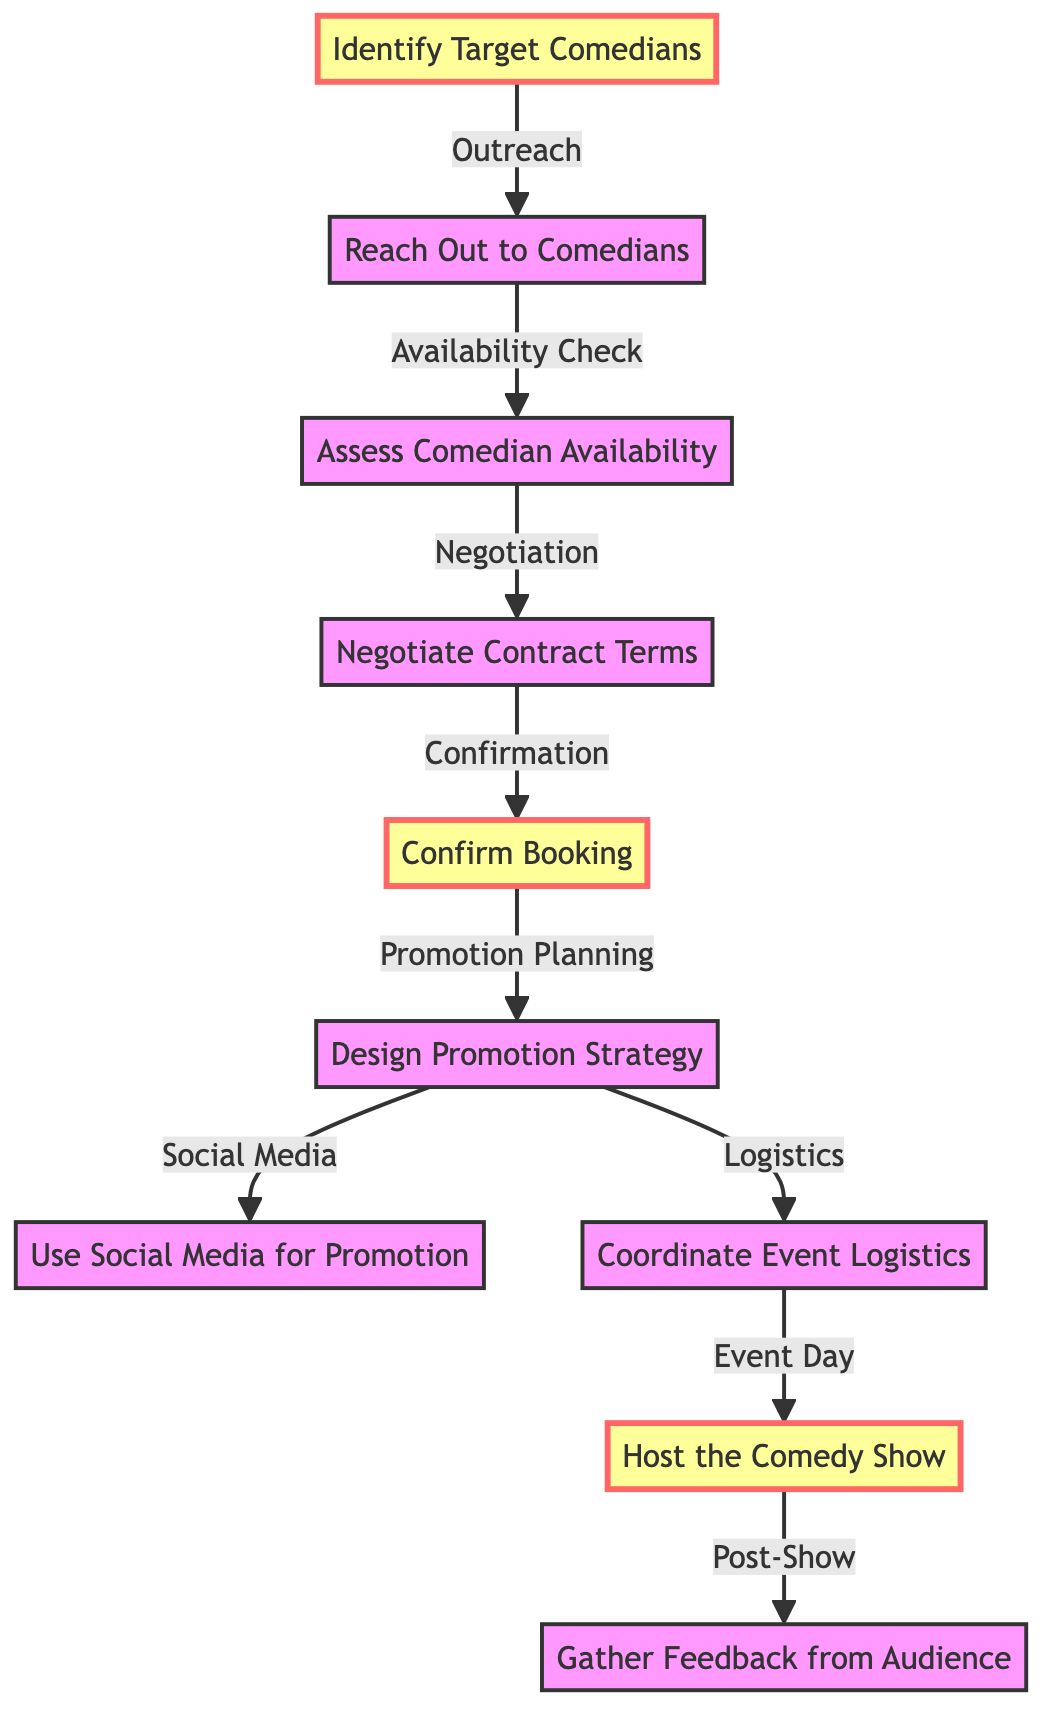What is the first step in the comedy show booking process? The diagram shows that the first step is represented by node "1", which is "Identify Target Comedians".
Answer: Identify Target Comedians How many total nodes are present in the diagram? Counting each unique labeled node in the diagram, there are a total of 10 nodes.
Answer: 10 What follows after confirming the booking? From the diagram, after "Confirm Booking", the next step is "Design Promotion Strategy", indicated by the connection from node "5" to node "6".
Answer: Design Promotion Strategy What is the last step of the comedy show booking process? The last step is represented by node "10", which is "Gather Feedback from Audience".
Answer: Gather Feedback from Audience Which step involves checking a comedian's availability? The option that includes checking availability is "Assess Comedian Availability", as indicated by node "3", which follows after "Reach Out to Comedians" (node "2").
Answer: Assess Comedian Availability What are the two parallel strategies developed after designing the promotion strategy? The diagram shows that from "Design Promotion Strategy" (node "6"), there are two parallel connections to "Use Social Media for Promotion" (node "7") and "Coordinate Event Logistics" (node "8").
Answer: Use Social Media for Promotion and Coordinate Event Logistics Which node connects to hosting the comedy show? "Host the Comedy Show" is indicated by node "9", which connects from "Coordinate Event Logistics" (node "8").
Answer: Coordinate Event Logistics What type of connection exists between confirming booking and designing promotion strategy? The connection between "Confirm Booking" (node "5") and "Design Promotion Strategy" (node "6") is a direct progression in the booking process.
Answer: Progression 